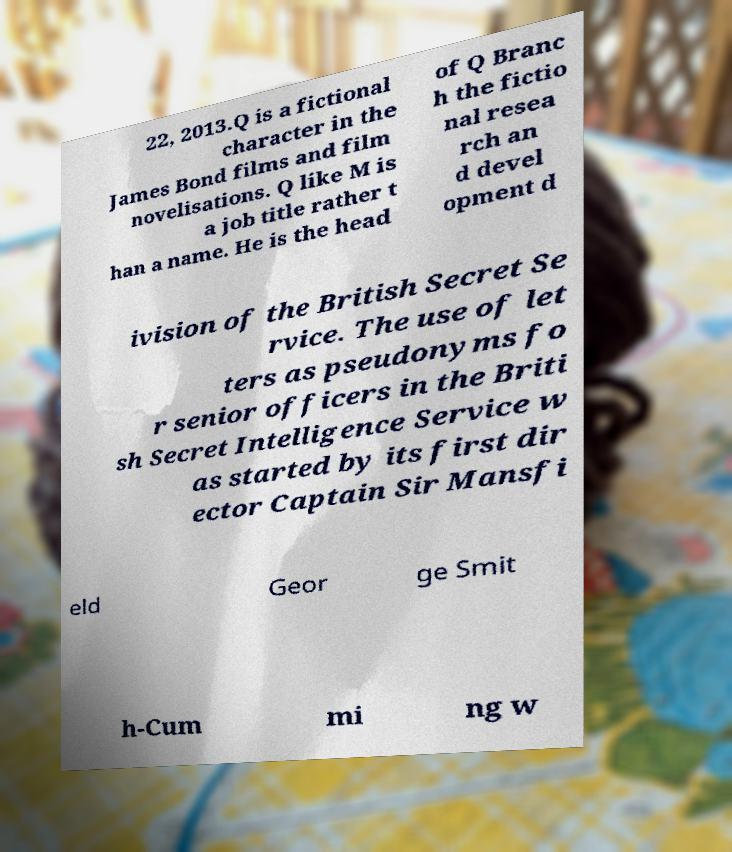Please identify and transcribe the text found in this image. 22, 2013.Q is a fictional character in the James Bond films and film novelisations. Q like M is a job title rather t han a name. He is the head of Q Branc h the fictio nal resea rch an d devel opment d ivision of the British Secret Se rvice. The use of let ters as pseudonyms fo r senior officers in the Briti sh Secret Intelligence Service w as started by its first dir ector Captain Sir Mansfi eld Geor ge Smit h-Cum mi ng w 